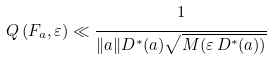<formula> <loc_0><loc_0><loc_500><loc_500>Q \left ( F _ { a } , \varepsilon \right ) \ll \cfrac { 1 } { \| a \| D ^ { * } ( a ) \sqrt { M ( \varepsilon \, D ^ { * } ( a ) ) } }</formula> 